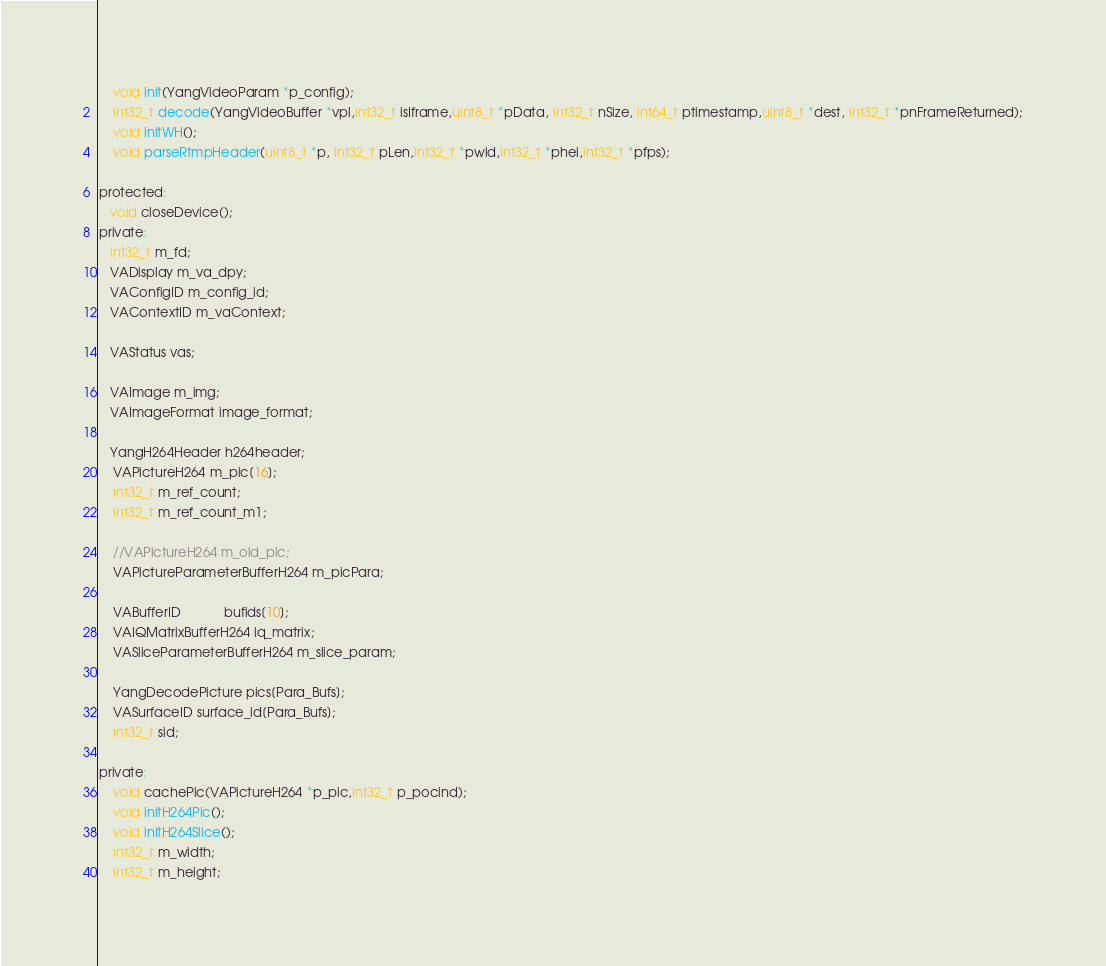<code> <loc_0><loc_0><loc_500><loc_500><_C_>    void init(YangVideoParam *p_config);
    int32_t decode(YangVideoBuffer *vpl,int32_t isIframe,uint8_t *pData, int32_t nSize, int64_t ptimestamp,uint8_t *dest, int32_t *pnFrameReturned);
    void initWH();
    void parseRtmpHeader(uint8_t *p, int32_t pLen,int32_t *pwid,int32_t *phei,int32_t *pfps);

protected:
   void closeDevice();
private:
   int32_t m_fd;
   VADisplay m_va_dpy;
   VAConfigID m_config_id;
   VAContextID m_vaContext;

   VAStatus vas;

   VAImage m_img;
   VAImageFormat image_format;

   YangH264Header h264header;
    VAPictureH264 m_pic[16];
    int32_t m_ref_count;
    int32_t m_ref_count_m1;

    //VAPictureH264 m_old_pic;
    VAPictureParameterBufferH264 m_picPara;

    VABufferID            bufids[10];
    VAIQMatrixBufferH264 iq_matrix;
    VASliceParameterBufferH264 m_slice_param;

    YangDecodePicture pics[Para_Bufs];
    VASurfaceID surface_id[Para_Bufs];
    int32_t sid;

private:
    void cachePic(VAPictureH264 *p_pic,int32_t p_pocind);
    void initH264Pic();
    void initH264Slice();
    int32_t m_width;
    int32_t m_height;</code> 